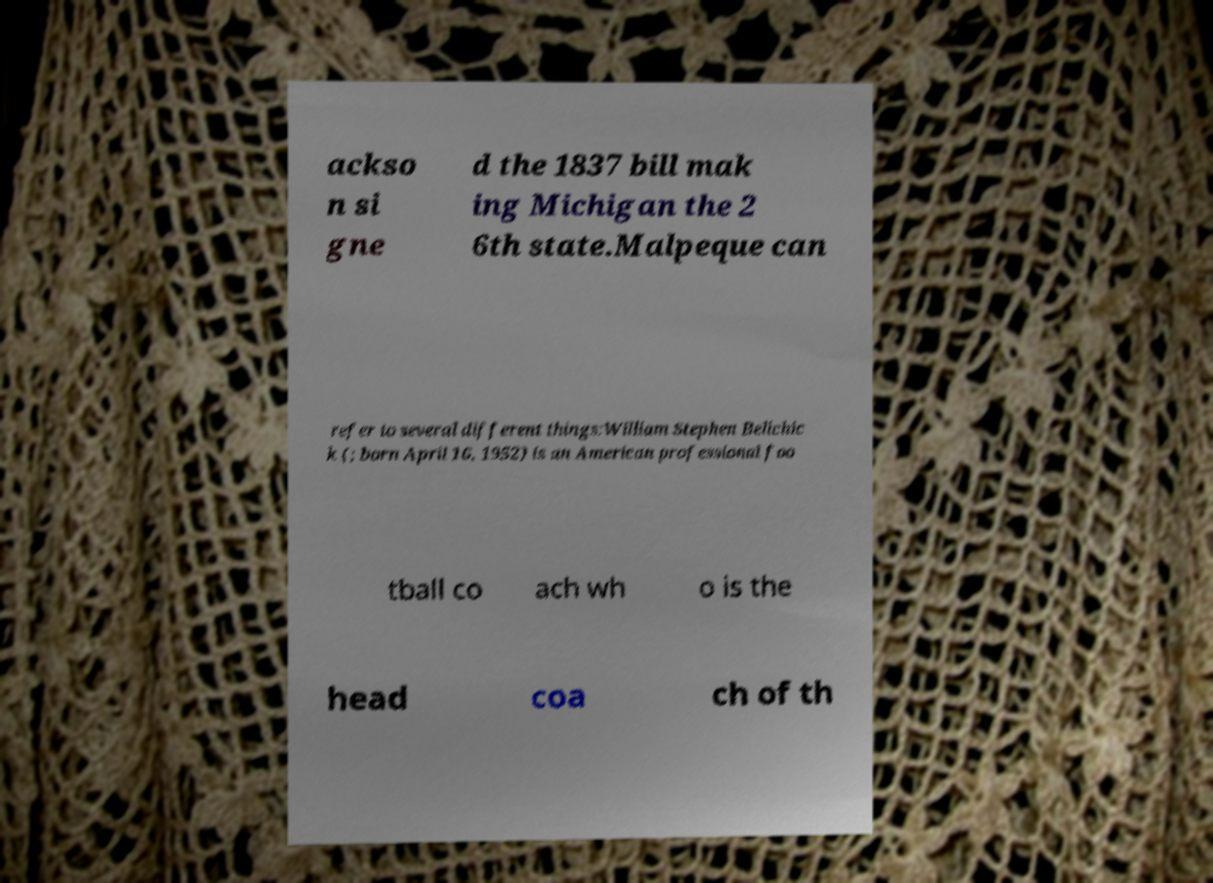There's text embedded in this image that I need extracted. Can you transcribe it verbatim? ackso n si gne d the 1837 bill mak ing Michigan the 2 6th state.Malpeque can refer to several different things:William Stephen Belichic k (; born April 16, 1952) is an American professional foo tball co ach wh o is the head coa ch of th 